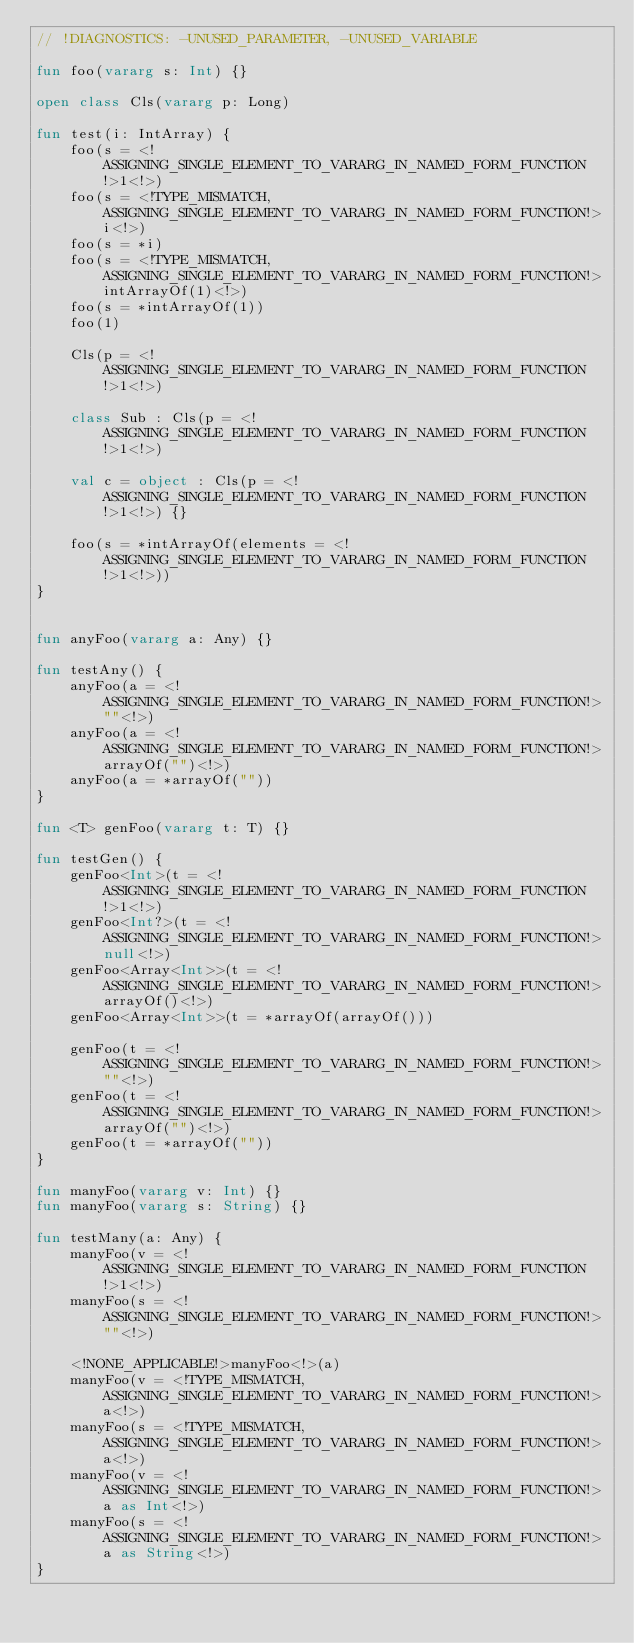Convert code to text. <code><loc_0><loc_0><loc_500><loc_500><_Kotlin_>// !DIAGNOSTICS: -UNUSED_PARAMETER, -UNUSED_VARIABLE

fun foo(vararg s: Int) {}

open class Cls(vararg p: Long)

fun test(i: IntArray) {
    foo(s = <!ASSIGNING_SINGLE_ELEMENT_TO_VARARG_IN_NAMED_FORM_FUNCTION!>1<!>)
    foo(s = <!TYPE_MISMATCH, ASSIGNING_SINGLE_ELEMENT_TO_VARARG_IN_NAMED_FORM_FUNCTION!>i<!>)
    foo(s = *i)
    foo(s = <!TYPE_MISMATCH, ASSIGNING_SINGLE_ELEMENT_TO_VARARG_IN_NAMED_FORM_FUNCTION!>intArrayOf(1)<!>)
    foo(s = *intArrayOf(1))
    foo(1)

    Cls(p = <!ASSIGNING_SINGLE_ELEMENT_TO_VARARG_IN_NAMED_FORM_FUNCTION!>1<!>)

    class Sub : Cls(p = <!ASSIGNING_SINGLE_ELEMENT_TO_VARARG_IN_NAMED_FORM_FUNCTION!>1<!>)

    val c = object : Cls(p = <!ASSIGNING_SINGLE_ELEMENT_TO_VARARG_IN_NAMED_FORM_FUNCTION!>1<!>) {}

    foo(s = *intArrayOf(elements = <!ASSIGNING_SINGLE_ELEMENT_TO_VARARG_IN_NAMED_FORM_FUNCTION!>1<!>))
}


fun anyFoo(vararg a: Any) {}

fun testAny() {
    anyFoo(a = <!ASSIGNING_SINGLE_ELEMENT_TO_VARARG_IN_NAMED_FORM_FUNCTION!>""<!>)
    anyFoo(a = <!ASSIGNING_SINGLE_ELEMENT_TO_VARARG_IN_NAMED_FORM_FUNCTION!>arrayOf("")<!>)
    anyFoo(a = *arrayOf(""))
}

fun <T> genFoo(vararg t: T) {}

fun testGen() {
    genFoo<Int>(t = <!ASSIGNING_SINGLE_ELEMENT_TO_VARARG_IN_NAMED_FORM_FUNCTION!>1<!>)
    genFoo<Int?>(t = <!ASSIGNING_SINGLE_ELEMENT_TO_VARARG_IN_NAMED_FORM_FUNCTION!>null<!>)
    genFoo<Array<Int>>(t = <!ASSIGNING_SINGLE_ELEMENT_TO_VARARG_IN_NAMED_FORM_FUNCTION!>arrayOf()<!>)
    genFoo<Array<Int>>(t = *arrayOf(arrayOf()))

    genFoo(t = <!ASSIGNING_SINGLE_ELEMENT_TO_VARARG_IN_NAMED_FORM_FUNCTION!>""<!>)
    genFoo(t = <!ASSIGNING_SINGLE_ELEMENT_TO_VARARG_IN_NAMED_FORM_FUNCTION!>arrayOf("")<!>)
    genFoo(t = *arrayOf(""))
}

fun manyFoo(vararg v: Int) {}
fun manyFoo(vararg s: String) {}

fun testMany(a: Any) {
    manyFoo(v = <!ASSIGNING_SINGLE_ELEMENT_TO_VARARG_IN_NAMED_FORM_FUNCTION!>1<!>)
    manyFoo(s = <!ASSIGNING_SINGLE_ELEMENT_TO_VARARG_IN_NAMED_FORM_FUNCTION!>""<!>)

    <!NONE_APPLICABLE!>manyFoo<!>(a)
    manyFoo(v = <!TYPE_MISMATCH, ASSIGNING_SINGLE_ELEMENT_TO_VARARG_IN_NAMED_FORM_FUNCTION!>a<!>)
    manyFoo(s = <!TYPE_MISMATCH, ASSIGNING_SINGLE_ELEMENT_TO_VARARG_IN_NAMED_FORM_FUNCTION!>a<!>)
    manyFoo(v = <!ASSIGNING_SINGLE_ELEMENT_TO_VARARG_IN_NAMED_FORM_FUNCTION!>a as Int<!>)
    manyFoo(s = <!ASSIGNING_SINGLE_ELEMENT_TO_VARARG_IN_NAMED_FORM_FUNCTION!>a as String<!>)
}</code> 